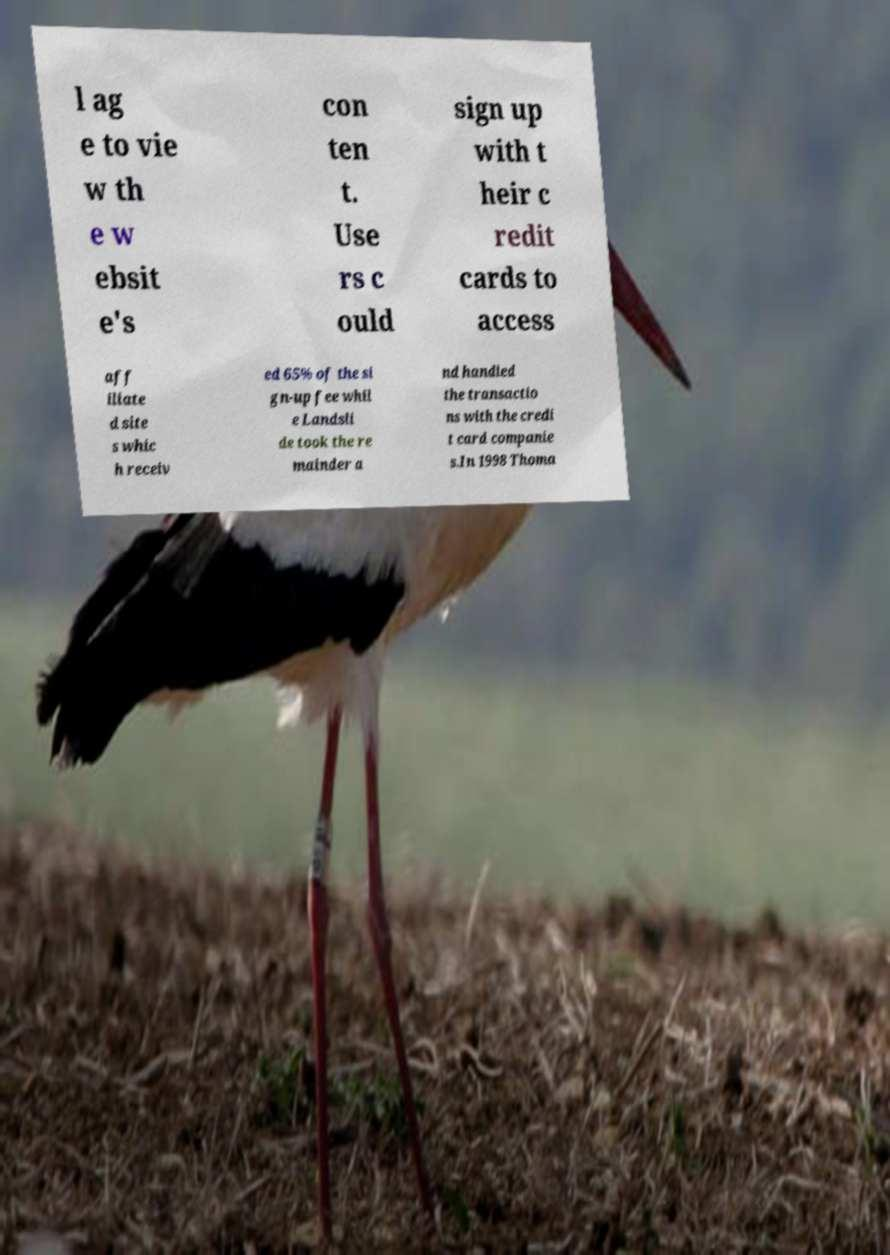For documentation purposes, I need the text within this image transcribed. Could you provide that? l ag e to vie w th e w ebsit e's con ten t. Use rs c ould sign up with t heir c redit cards to access aff iliate d site s whic h receiv ed 65% of the si gn-up fee whil e Landsli de took the re mainder a nd handled the transactio ns with the credi t card companie s.In 1998 Thoma 